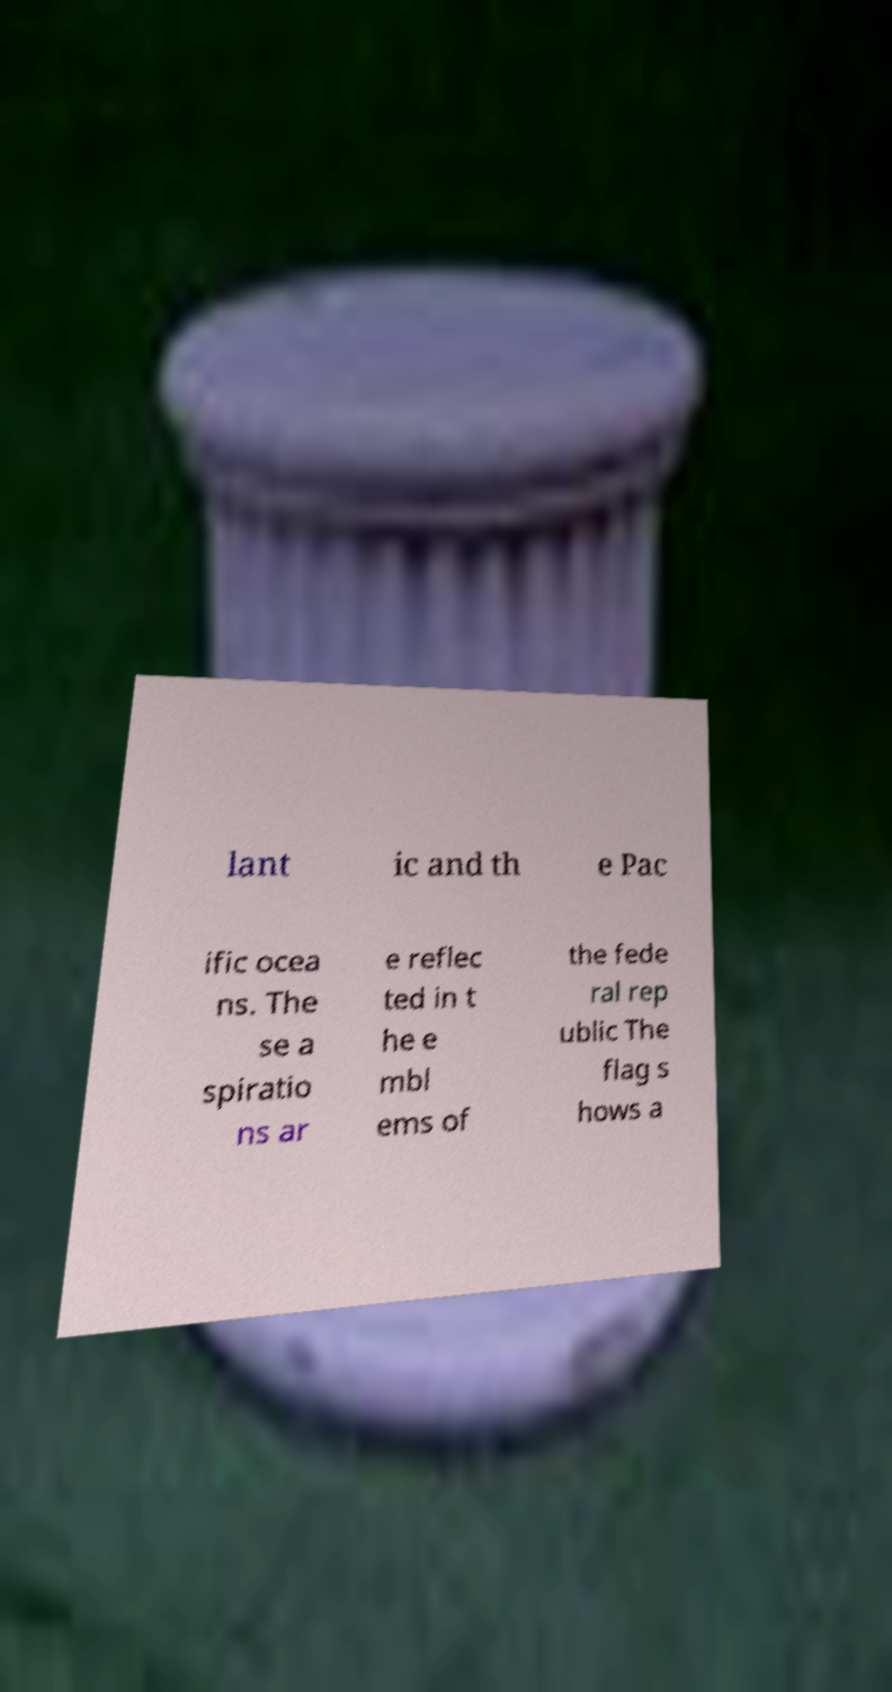There's text embedded in this image that I need extracted. Can you transcribe it verbatim? lant ic and th e Pac ific ocea ns. The se a spiratio ns ar e reflec ted in t he e mbl ems of the fede ral rep ublic The flag s hows a 